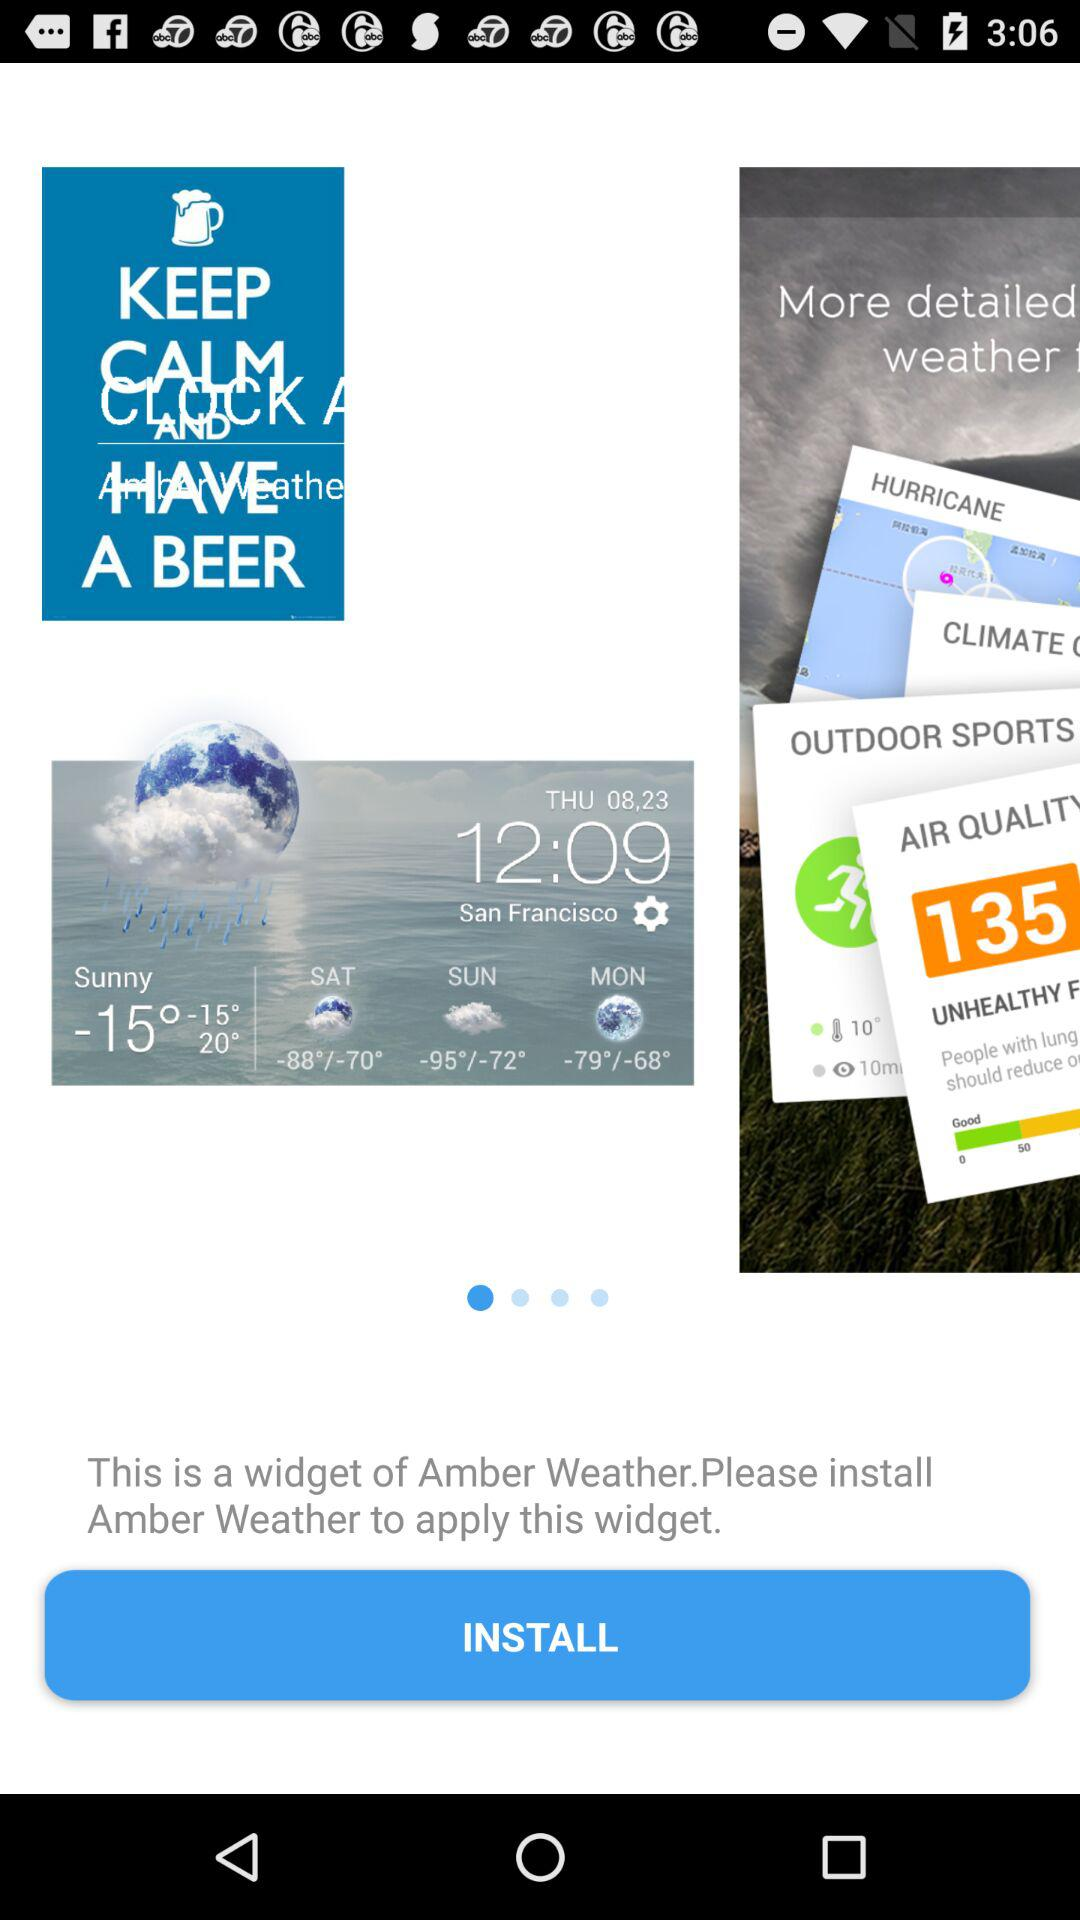What's the weather in San Francisco? The weather is "Sunny". 